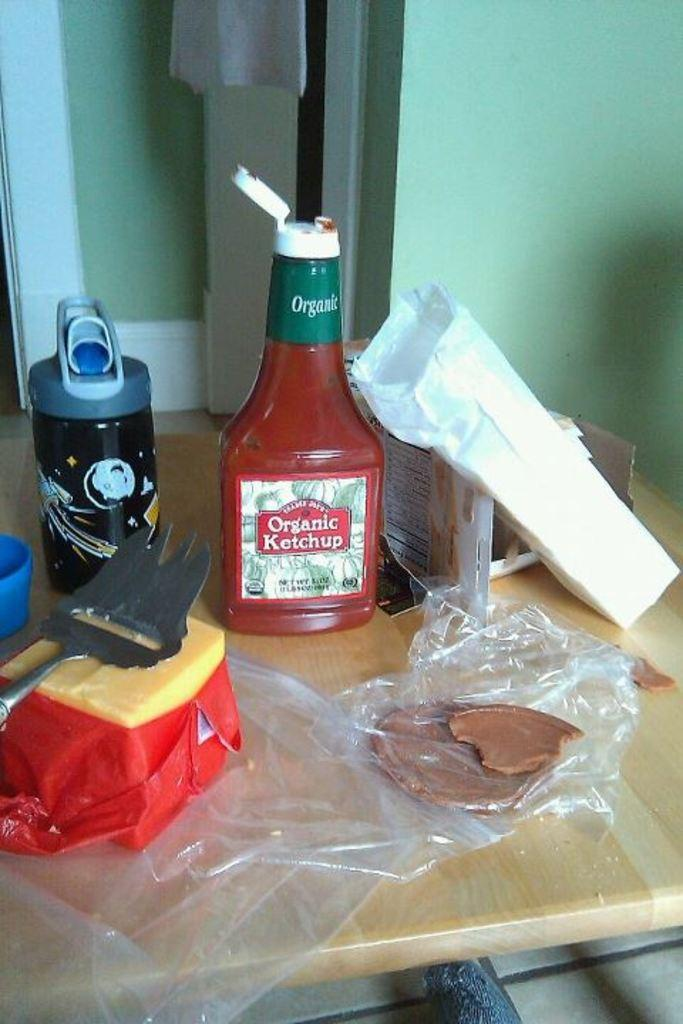<image>
Offer a succinct explanation of the picture presented. A bottle of organic ketchup sits on a wooden table with meat and cheese. 